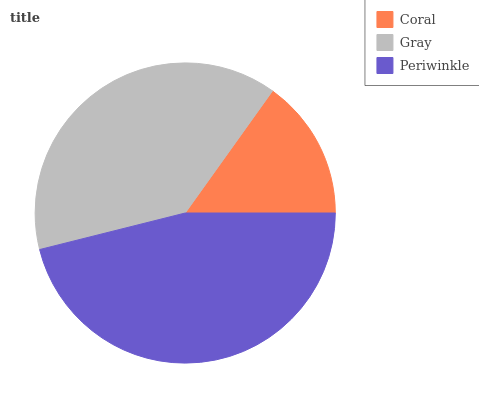Is Coral the minimum?
Answer yes or no. Yes. Is Periwinkle the maximum?
Answer yes or no. Yes. Is Gray the minimum?
Answer yes or no. No. Is Gray the maximum?
Answer yes or no. No. Is Gray greater than Coral?
Answer yes or no. Yes. Is Coral less than Gray?
Answer yes or no. Yes. Is Coral greater than Gray?
Answer yes or no. No. Is Gray less than Coral?
Answer yes or no. No. Is Gray the high median?
Answer yes or no. Yes. Is Gray the low median?
Answer yes or no. Yes. Is Periwinkle the high median?
Answer yes or no. No. Is Periwinkle the low median?
Answer yes or no. No. 